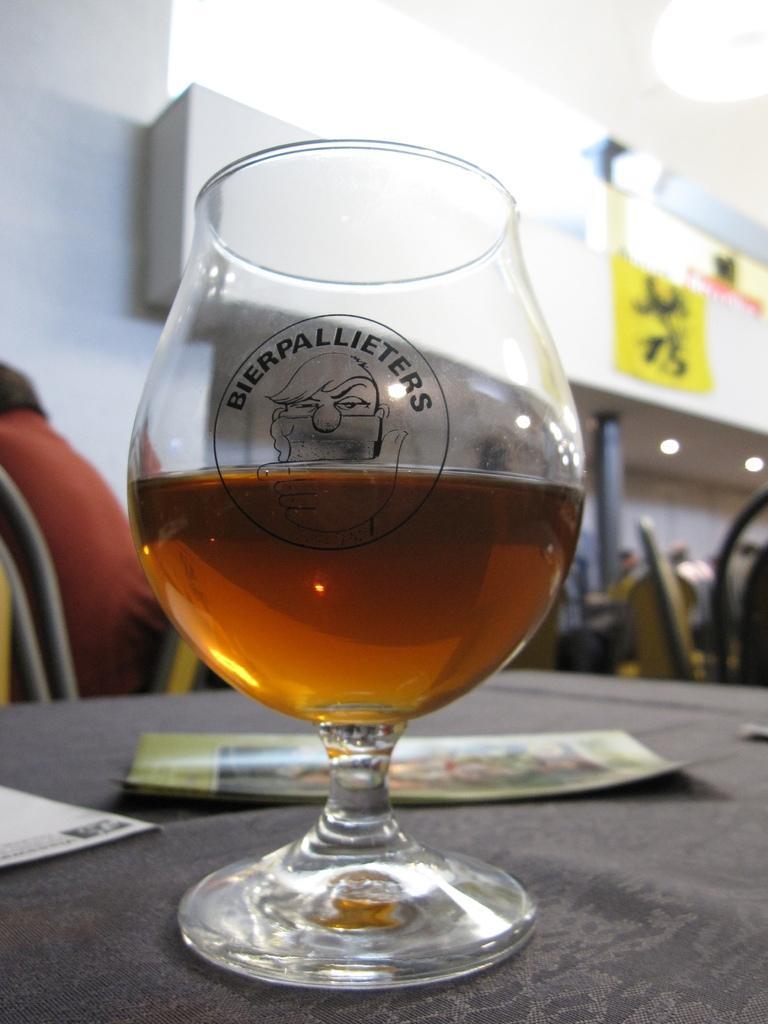In one or two sentences, can you explain what this image depicts? In this picture I can see a glass and couple of papers on the table and I can see a human seated on the chair and I can see few chairs and It looks like a inner view of a building and I can see few lights on the ceiling. 